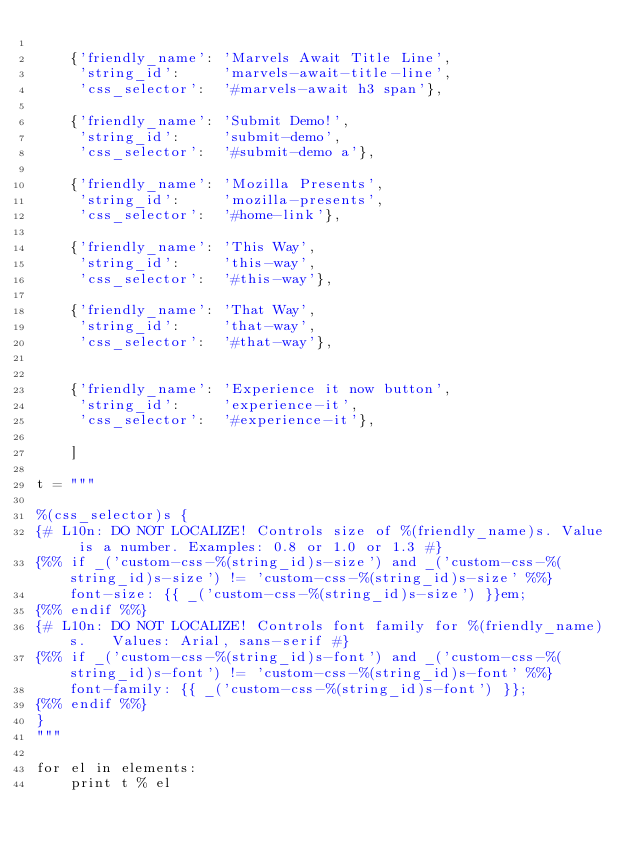Convert code to text. <code><loc_0><loc_0><loc_500><loc_500><_Python_>
    {'friendly_name': 'Marvels Await Title Line', 
     'string_id':     'marvels-await-title-line',
     'css_selector':  '#marvels-await h3 span'},

    {'friendly_name': 'Submit Demo!', 
     'string_id':     'submit-demo',
     'css_selector':  '#submit-demo a'},

    {'friendly_name': 'Mozilla Presents', 
     'string_id':     'mozilla-presents',
     'css_selector':  '#home-link'},

    {'friendly_name': 'This Way', 
     'string_id':     'this-way',
     'css_selector':  '#this-way'},

    {'friendly_name': 'That Way', 
     'string_id':     'that-way',
     'css_selector':  '#that-way'},


    {'friendly_name': 'Experience it now button', 
     'string_id':     'experience-it',
     'css_selector':  '#experience-it'},

    ]

t = """

%(css_selector)s {
{# L10n: DO NOT LOCALIZE! Controls size of %(friendly_name)s. Value is a number. Examples: 0.8 or 1.0 or 1.3 #}
{%% if _('custom-css-%(string_id)s-size') and _('custom-css-%(string_id)s-size') != 'custom-css-%(string_id)s-size' %%}
    font-size: {{ _('custom-css-%(string_id)s-size') }}em;
{%% endif %%}
{# L10n: DO NOT LOCALIZE! Controls font family for %(friendly_name)s.   Values: Arial, sans-serif #}
{%% if _('custom-css-%(string_id)s-font') and _('custom-css-%(string_id)s-font') != 'custom-css-%(string_id)s-font' %%}
    font-family: {{ _('custom-css-%(string_id)s-font') }};
{%% endif %%}
}
"""

for el in elements:
    print t % el
</code> 